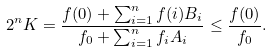<formula> <loc_0><loc_0><loc_500><loc_500>2 ^ { n } K = \frac { f ( 0 ) + \sum _ { i = 1 } ^ { n } f ( i ) B _ { i } } { f _ { 0 } + \sum _ { i = 1 } ^ { n } f _ { i } A _ { i } } \leq \frac { f ( 0 ) } { f _ { 0 } } .</formula> 